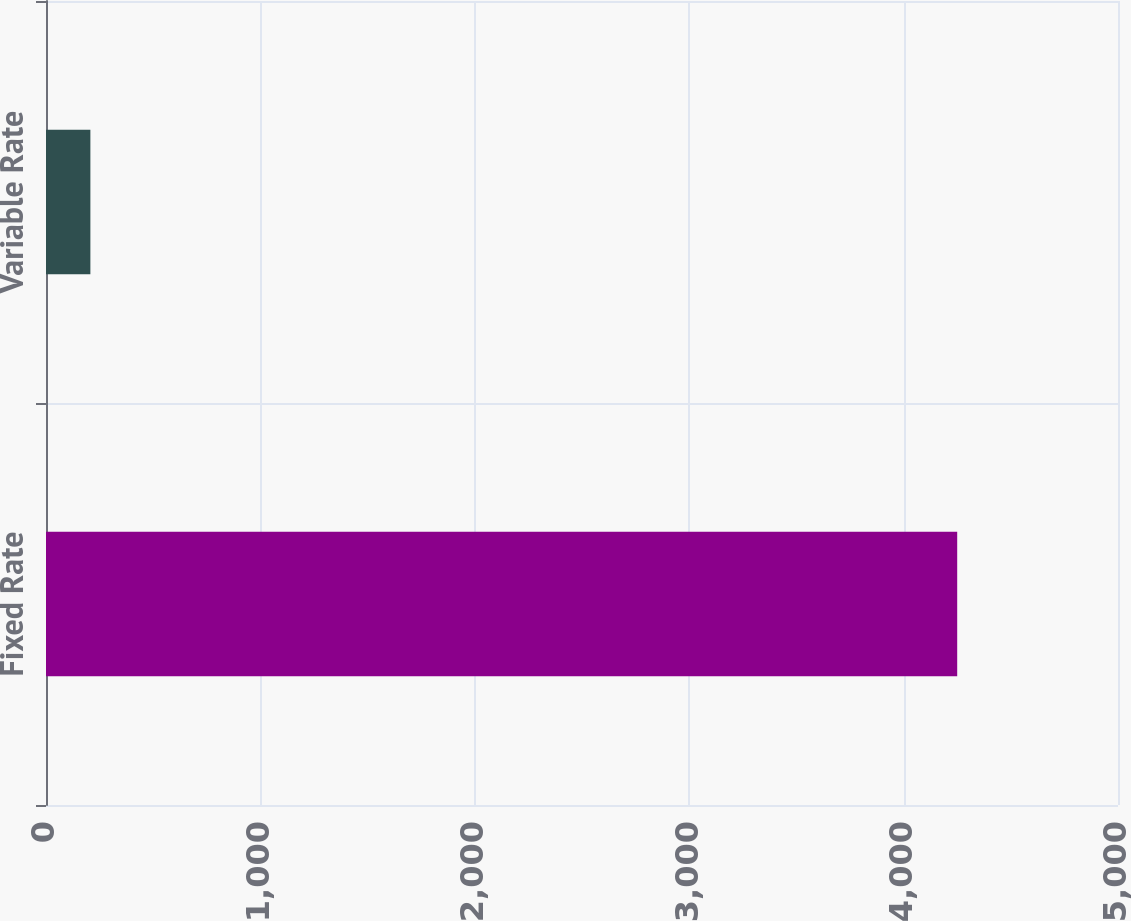<chart> <loc_0><loc_0><loc_500><loc_500><bar_chart><fcel>Fixed Rate<fcel>Variable Rate<nl><fcel>4250<fcel>207<nl></chart> 